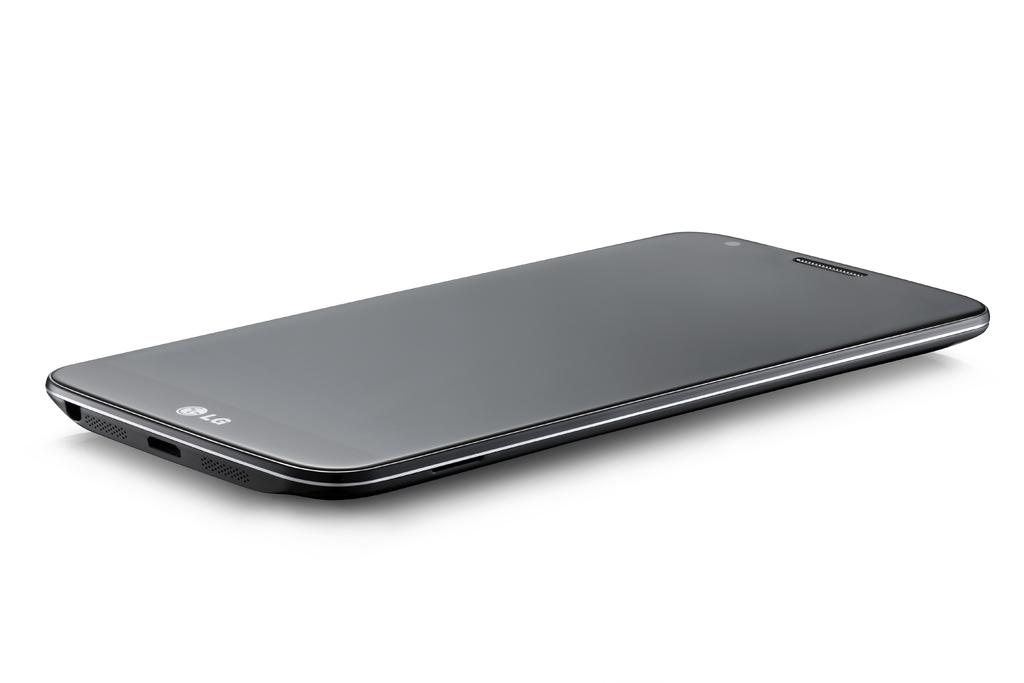<image>
Write a terse but informative summary of the picture. A sleek black Lg phone lies on it's back looking upward, it appears to be new. 